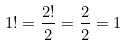<formula> <loc_0><loc_0><loc_500><loc_500>1 ! = \frac { 2 ! } { 2 } = \frac { 2 } { 2 } = 1</formula> 